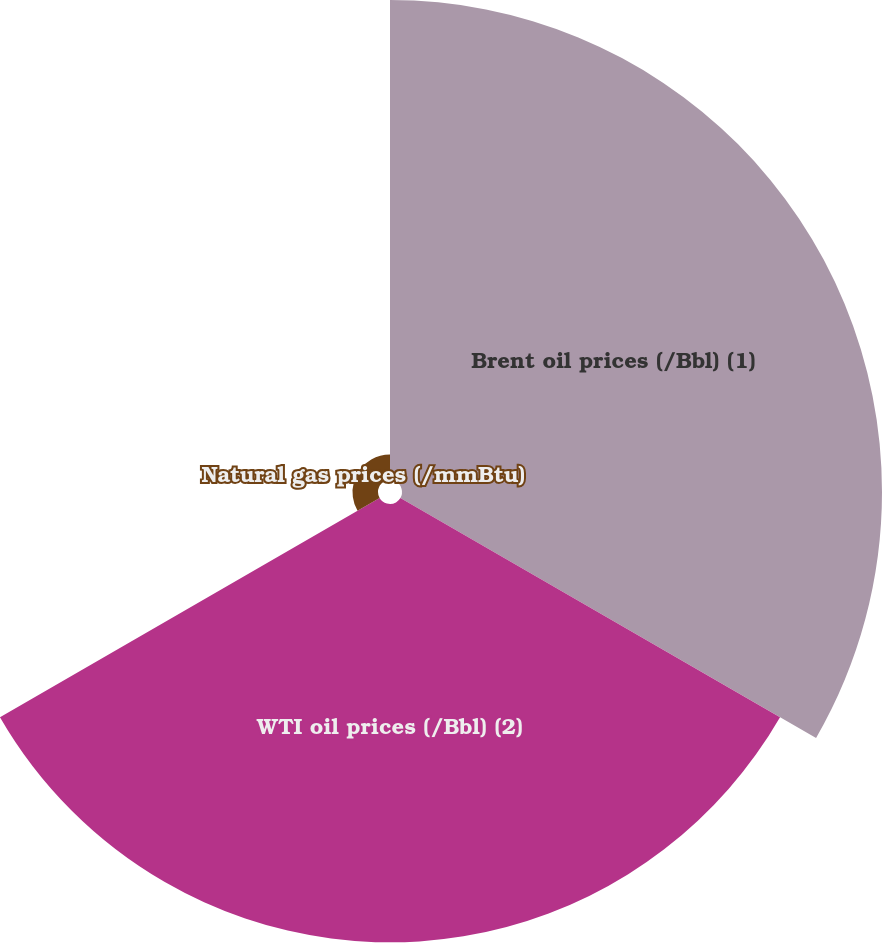Convert chart to OTSL. <chart><loc_0><loc_0><loc_500><loc_500><pie_chart><fcel>Brent oil prices (/Bbl) (1)<fcel>WTI oil prices (/Bbl) (2)<fcel>Natural gas prices (/mmBtu)<nl><fcel>50.85%<fcel>46.44%<fcel>2.7%<nl></chart> 